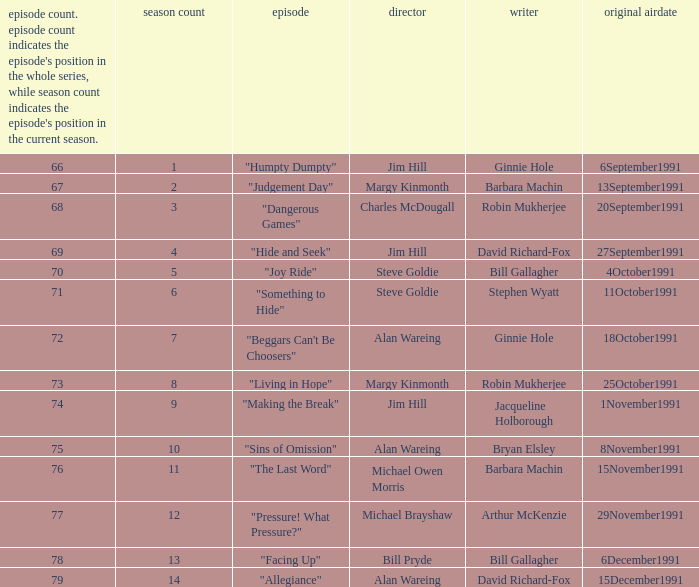Name the original airdate for robin mukherjee and margy kinmonth 25October1991. 